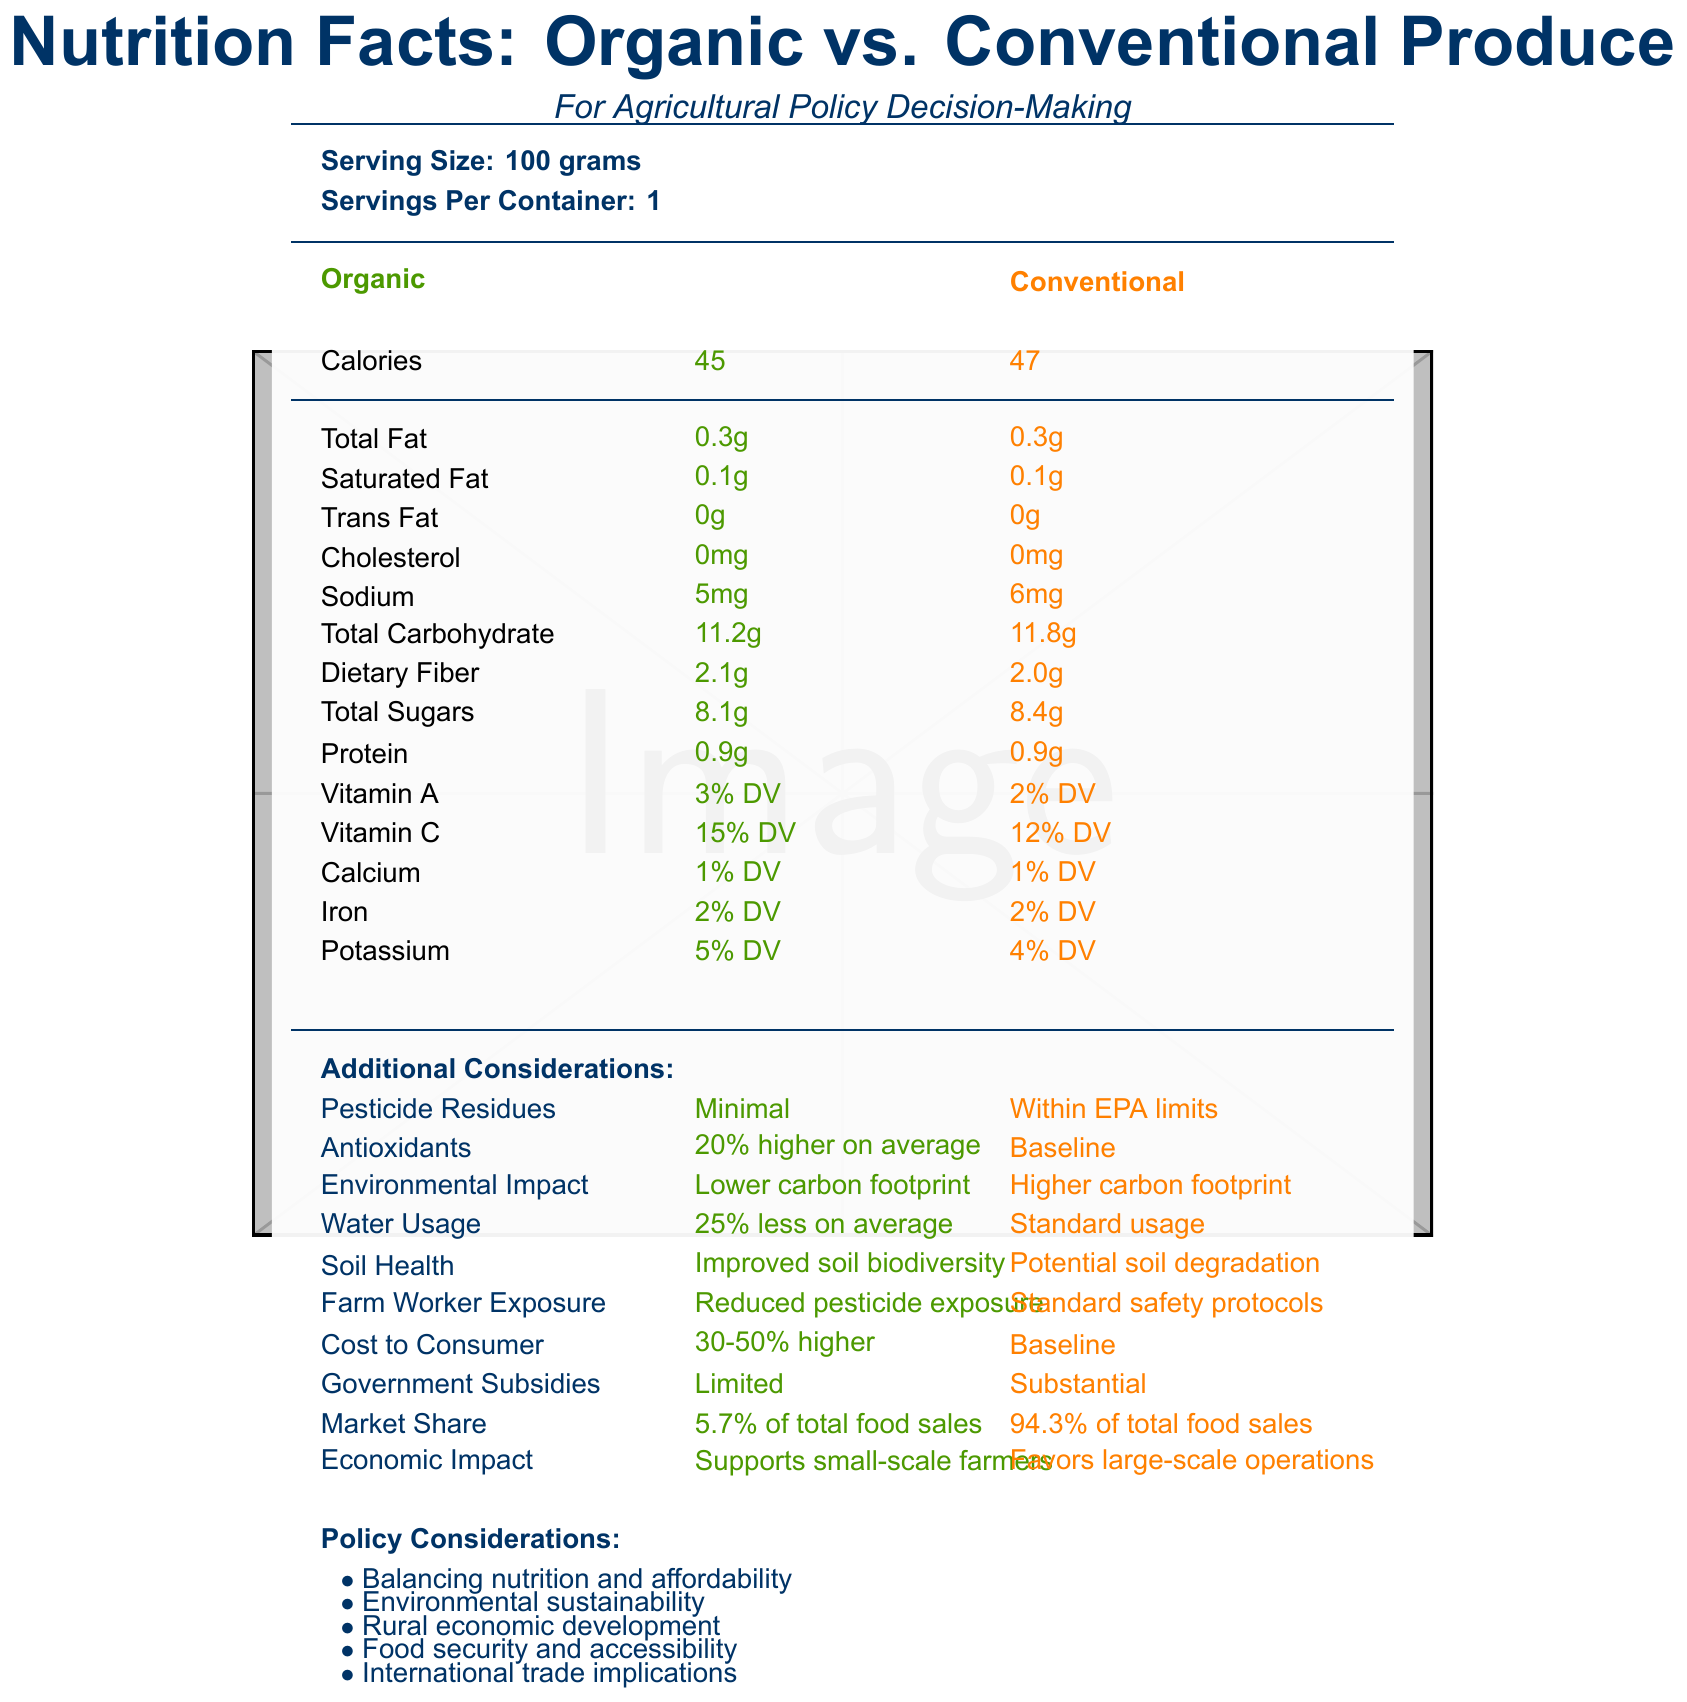what is the serving size? The document clearly states the serving size as 100 grams.
Answer: 100 grams how many calories are in a serving of organic produce? The nutrition facts label shows that organic produce contains 45 calories per serving.
Answer: 45 calories what is the difference in sodium content between organic and conventional produce? Organic produce has 5 mg of sodium, while conventional produce has 6 mg, making the difference 1 mg.
Answer: 1 mg does conventional produce have more or less dietary fiber than organic produce? The document shows that organic produce has 2.1g of dietary fiber, while conventional produce has 2.0g.
Answer: Less how much higher is the cost to the consumer for organic produce compared to conventional produce? The label mentions that the cost to consumer for organic produce is 30-50% higher than that of conventional produce.
Answer: 30-50% which type of produce has a higher Vitamin C content? A. Organic B. Conventional The document states that organic produce has 15% DV of Vitamin C, while conventional produce has 12% DV. Therefore, organic produce has a higher Vitamin C content.
Answer: A which type of produce supports small-scale farmers? i. Organic ii. Conventional iii. Both iv. Neither The label notes that organic produce supports small-scale farmers, while conventional produce favors large-scale operations.
Answer: i is the amount of trans fat in organic and conventional produce the same? Both types of produce contain 0g of trans fat, according to the document.
Answer: Yes summarize the key differences highlighted in the nutrition facts label between organic and conventional produce. The label compares organic and conventional produce in terms of nutrition, pesticide residues, environmental impact, cost, market share, economic impact, and other factors important for agricultural policy decisions.
Answer: Organic produce has lower calories, slightly different nutrient contents (higher in Vitamin A and C, and potassium), minimal pesticide residues, higher antioxidants, lower environmental impact, reduced water usage, and improved soil health compared to conventional produce. Additionally, organic produce costs 30-50% more, supports small-scale farmers, receives limited government subsidies, and holds a smaller market share. how much cholesterol is in conventional produce? The document lists the cholesterol content in both organic and conventional produce as 0mg.
Answer: 0mg is the market share of conventional produce about 95%? The document states that conventional produce holds 94.3% of the market share, which is approximately 95%.
Answer: Yes what are the pesticide residues in organic produce compared to conventional produce? The document indicates that organic produce has minimal pesticide residues, while conventional produce residues are within EPA limits.
Answer: Minimal/Within EPA limits what are the factors to consider in agricultural policy decisions as mentioned in the document? The document lists these policy considerations explicitly as important factors in deciding agricultural policies.
Answer: Balancing nutrition and affordability, Environmental sustainability, Rural economic development, Food security and accessibility, International trade implications which type of produce uses more water? The label indicates that organic produce uses 25% less water on average compared to conventional produce, which has standard water usage.
Answer: Conventional what is the market share of organic produce in total food sales? The label states that organic produce accounts for 5.7% of total food sales.
Answer: 5.7% describe the antioxidants content in conventional produce. The document states that conventional produce has baseline levels of antioxidants.
Answer: Baseline how many servings per container? The document does not provide enough information about the number of servings per container.
Answer: Cannot be determined 